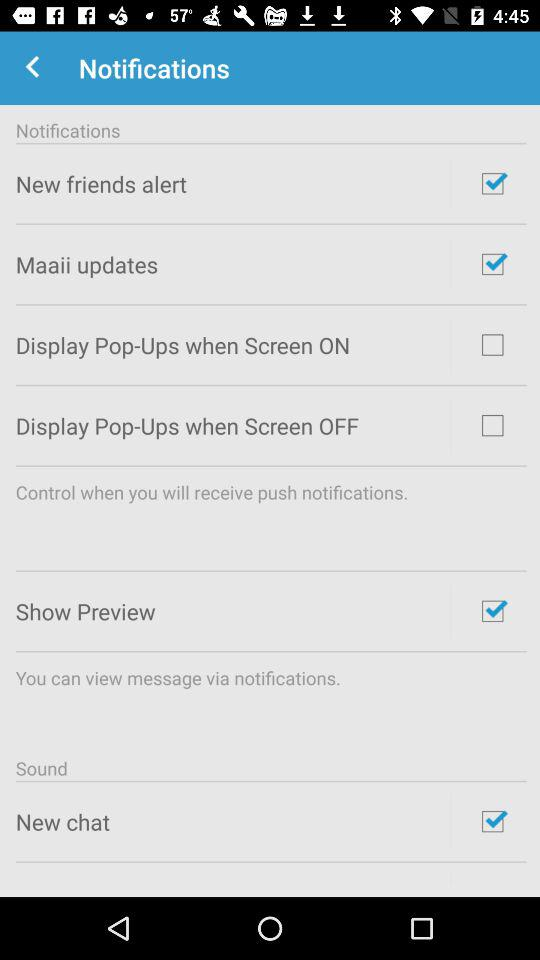What's the status of "New friend alert"? The status of "New friend alert" is "on". 